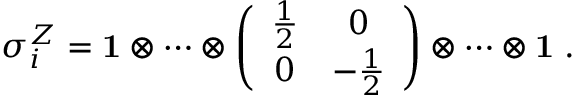Convert formula to latex. <formula><loc_0><loc_0><loc_500><loc_500>\sigma _ { i } ^ { Z } = { 1 } \otimes \cdots \otimes \left ( \begin{array} { c c } { { \frac { 1 } { 2 } } } & { 0 } \\ { 0 } & { { - \frac { 1 } { 2 } } } \end{array} \right ) \otimes \cdots \otimes { 1 } \, .</formula> 